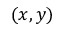Convert formula to latex. <formula><loc_0><loc_0><loc_500><loc_500>( x , y )</formula> 